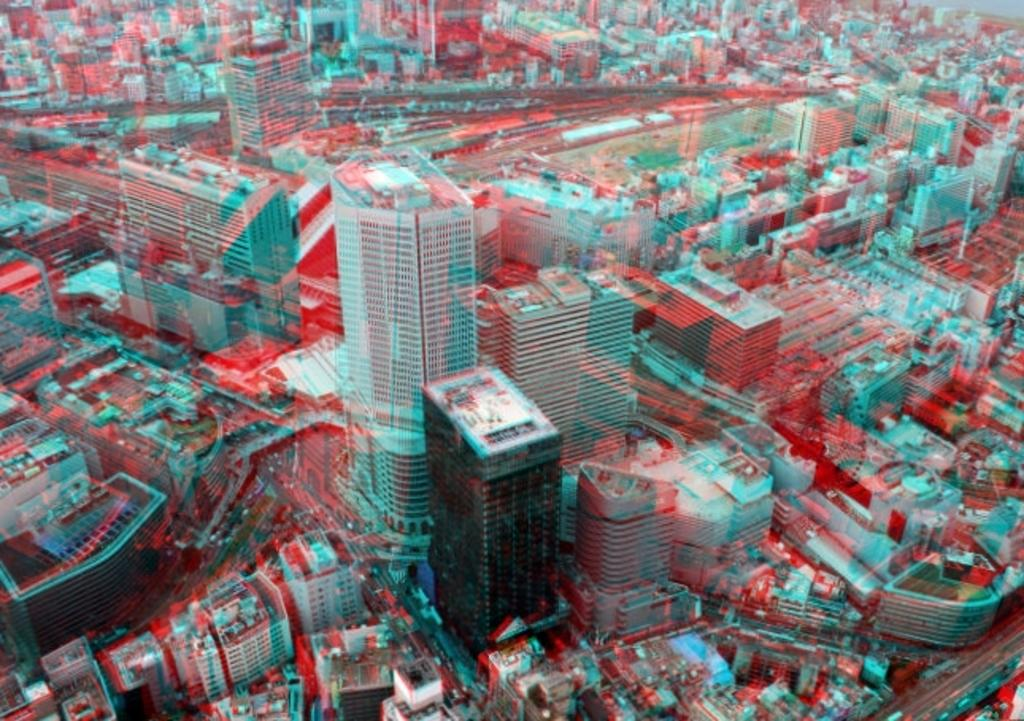What type of structures can be seen in the image? There are buildings in the image. What is visible beneath the buildings and vehicles? The ground is visible in the image. What else can be seen on the ground besides the buildings? There are objects like vehicles on the ground. Is there any architectural feature that connects two areas in the image? Yes, there is a bridge in the image. Where is the cactus located in the image? There is no cactus present in the image. What type of farming equipment can be seen in the image? There is no farming equipment, such as a plough, present in the image. 